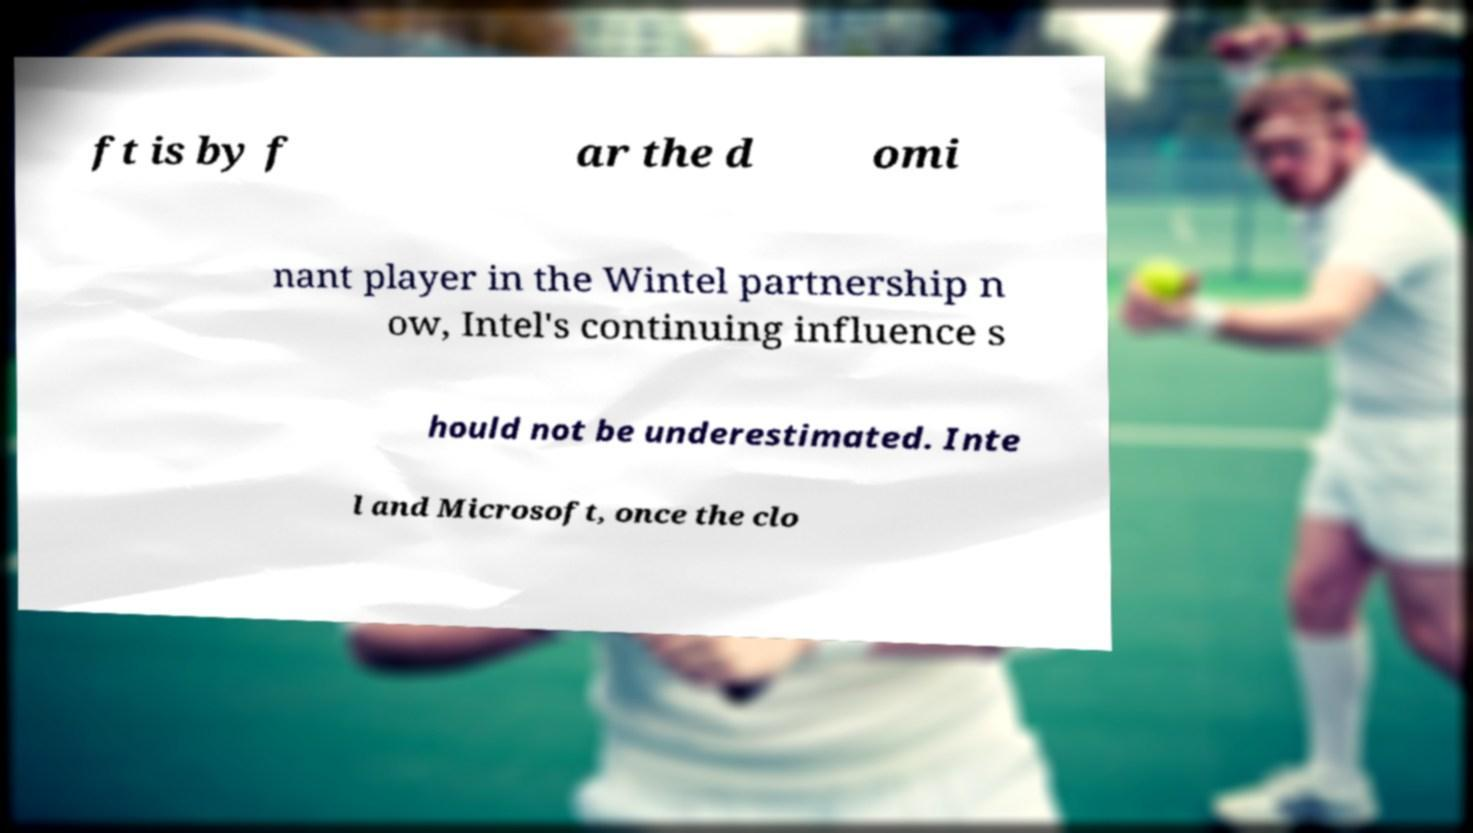Please identify and transcribe the text found in this image. ft is by f ar the d omi nant player in the Wintel partnership n ow, Intel's continuing influence s hould not be underestimated. Inte l and Microsoft, once the clo 